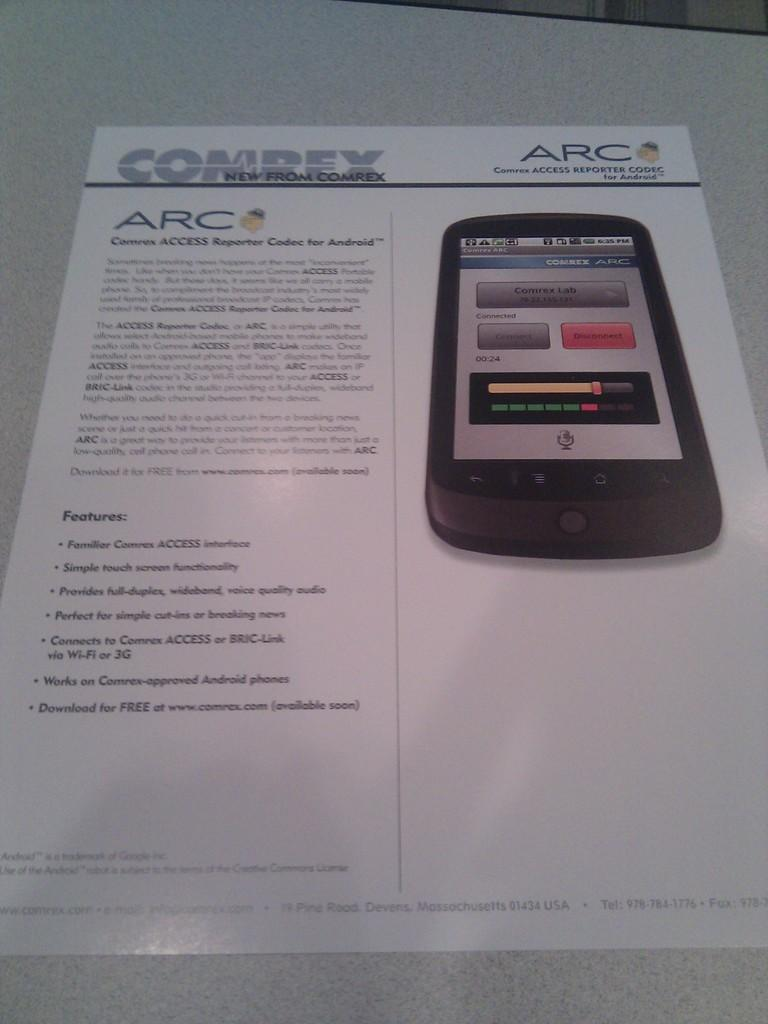<image>
Give a short and clear explanation of the subsequent image. An advertisement for a phone from the company ARC 